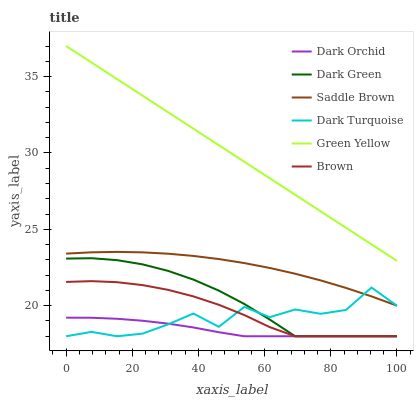Does Dark Orchid have the minimum area under the curve?
Answer yes or no. Yes. Does Green Yellow have the maximum area under the curve?
Answer yes or no. Yes. Does Dark Turquoise have the minimum area under the curve?
Answer yes or no. No. Does Dark Turquoise have the maximum area under the curve?
Answer yes or no. No. Is Green Yellow the smoothest?
Answer yes or no. Yes. Is Dark Turquoise the roughest?
Answer yes or no. Yes. Is Dark Orchid the smoothest?
Answer yes or no. No. Is Dark Orchid the roughest?
Answer yes or no. No. Does Brown have the lowest value?
Answer yes or no. Yes. Does Green Yellow have the lowest value?
Answer yes or no. No. Does Green Yellow have the highest value?
Answer yes or no. Yes. Does Dark Turquoise have the highest value?
Answer yes or no. No. Is Saddle Brown less than Green Yellow?
Answer yes or no. Yes. Is Saddle Brown greater than Dark Green?
Answer yes or no. Yes. Does Brown intersect Dark Orchid?
Answer yes or no. Yes. Is Brown less than Dark Orchid?
Answer yes or no. No. Is Brown greater than Dark Orchid?
Answer yes or no. No. Does Saddle Brown intersect Green Yellow?
Answer yes or no. No. 